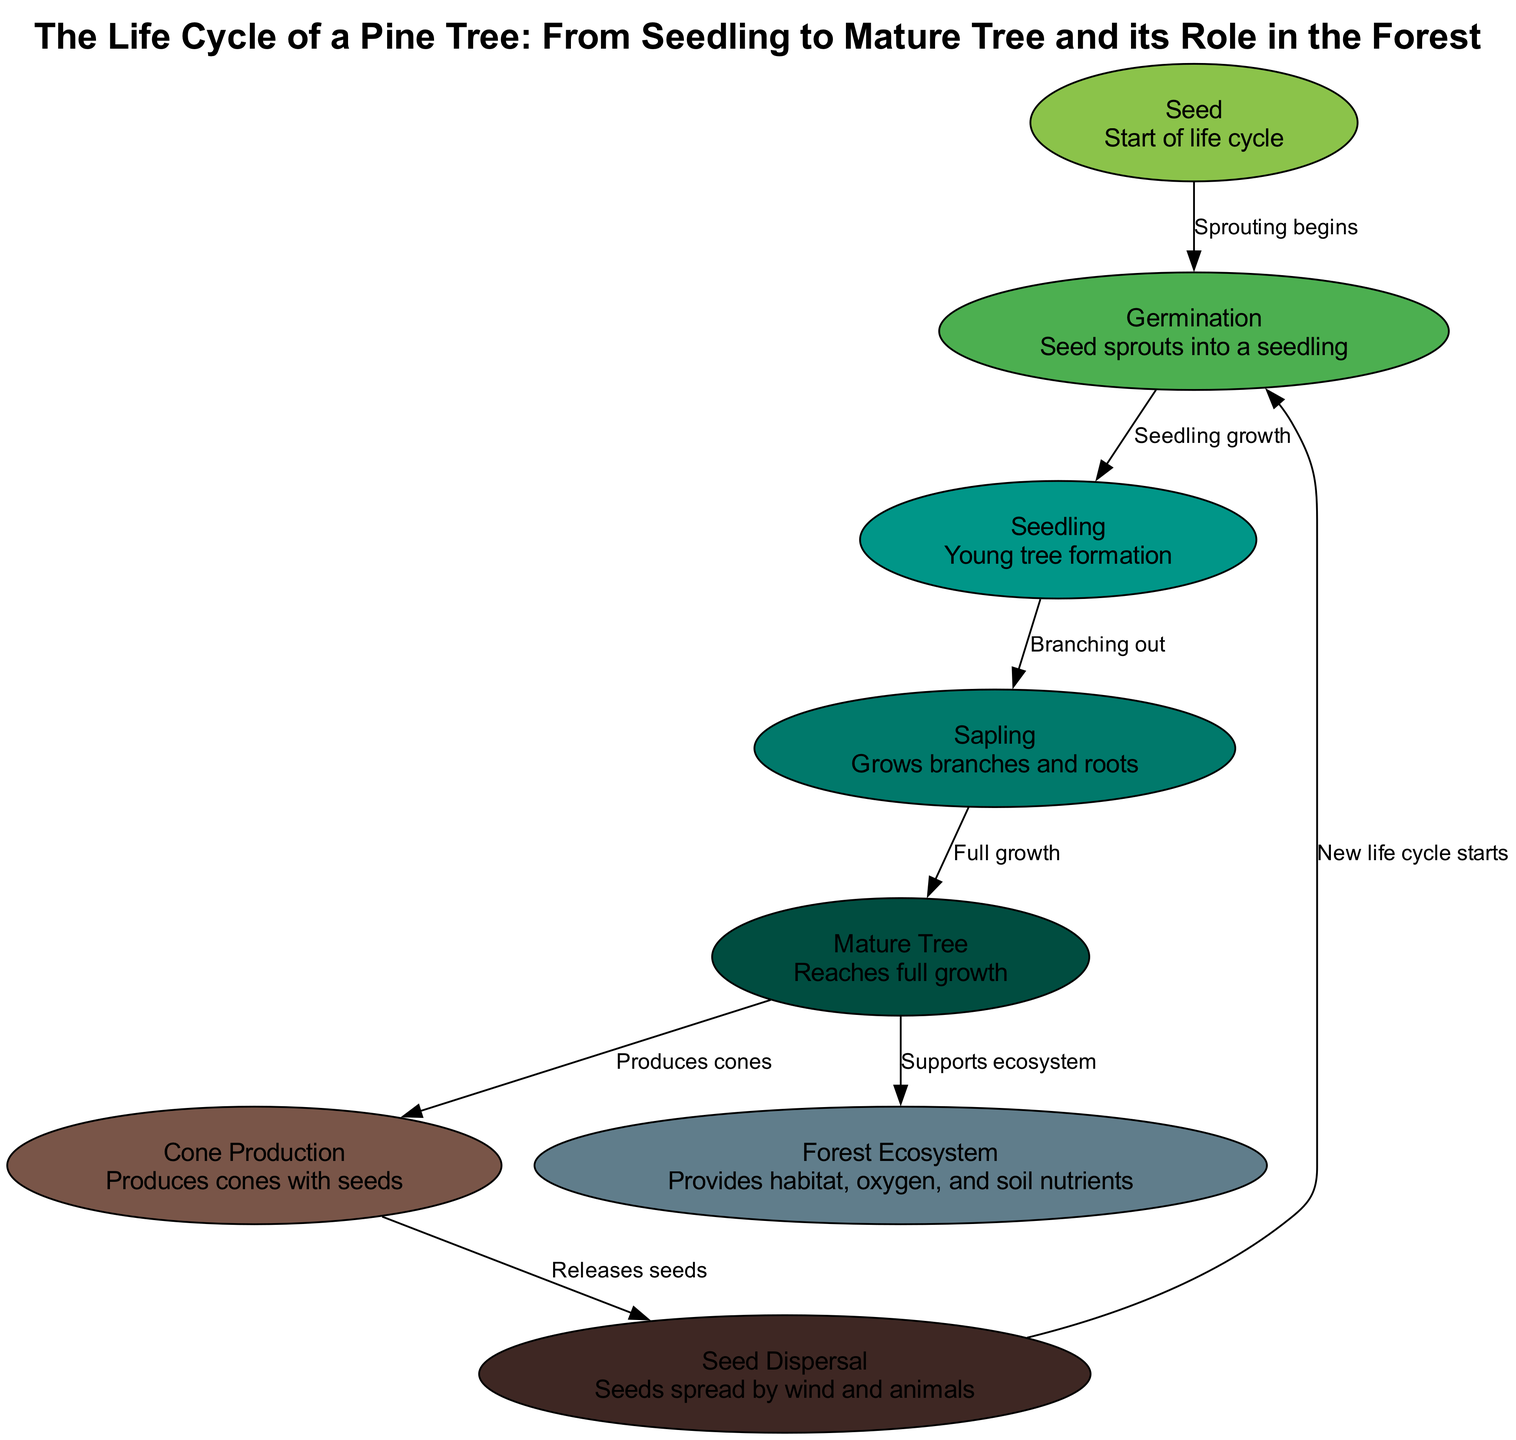What is the first stage in the life cycle of a pine tree? The diagram shows that the first node in the life cycle is labeled "Seed," which indicates the starting point of the cycle.
Answer: Seed How many stages are there in the life cycle of a pine tree? By counting the nodes in the diagram, there are a total of 8 distinct stages represented: Seed, Germination, Seedling, Sapling, Mature Tree, Cone Production, Seed Dispersal, and Forest Ecosystem.
Answer: 8 What process follows germination? The diagram indicates that after "Germination," the next step is "Seedling," as shown by the directed edge leading from germination to seedling.
Answer: Seedling What does the mature tree produce? According to the diagram, the "Mature Tree" stage then leads to "Cone Production," indicating that this is when the mature tree starts producing cones.
Answer: Cones How is seed dispersal related to germination? The diagram shows a connection where "Seed Dispersal" leads back to "Germination," indicating that seeds dispersed by wind and animals will later germinate and start the life cycle anew.
Answer: New life cycle starts Which stage supports the forest ecosystem? The diagram illustrates that the "Mature Tree" stage is connected to the "Forest Ecosystem," showing that mature trees play a role in supporting the overall ecosystem.
Answer: Mature Tree What happens during sapling growth? The diagram indicates that during the "Sapling" stage, the description includes "Grows branches and roots," which conveys how saplings develop structurally at this point in their life cycle.
Answer: Grows branches and roots What cycle starts after seed dispersal? The diagram indicates that after "Seed Dispersal," the flow returns to "Germination," which signifies the initiation of a new life cycle for the pine tree.
Answer: Germination What is the role of the forest ecosystem mentioned in the diagram? The diagram describes the "Forest Ecosystem" as providing "habitat, oxygen, and soil nutrients," indicating its importance in supporting life.
Answer: Habitat, oxygen, soil nutrients 